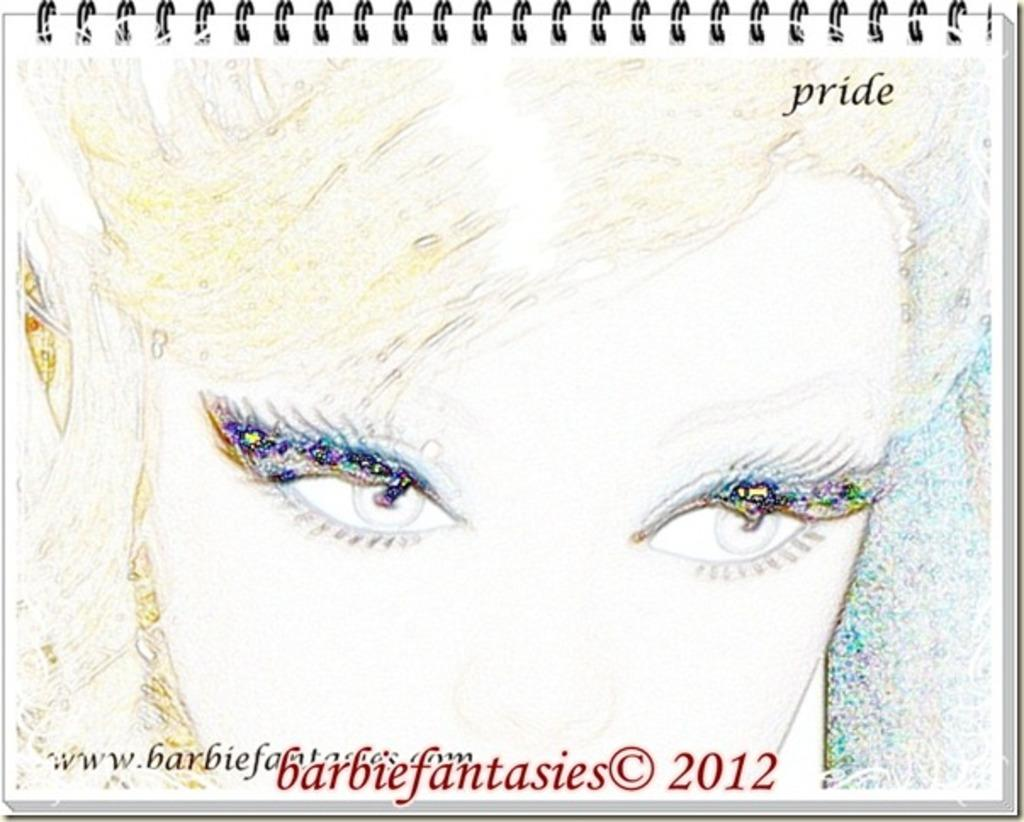What is depicted in the image? There is an animation of a person in the image. On what object is the animation placed? The animation is on some object. What design can be seen in the image? There is a spiral design in the image. Where is text located in the image? There is text at the bottom and top of the image. What type of fork can be seen in the image? There is no fork present in the image. What position is the person in the animation? The facts provided do not give information about the position of the person in the animation. 